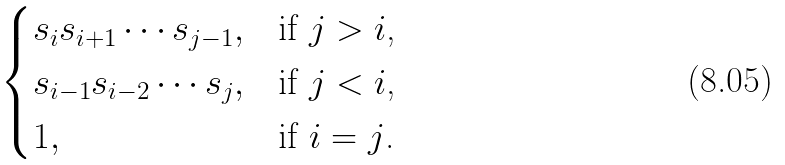<formula> <loc_0><loc_0><loc_500><loc_500>\begin{cases} s _ { i } s _ { i + 1 } \cdots s _ { j - 1 } , & \text {if $j>i$,} \\ s _ { i - 1 } s _ { i - 2 } \cdots s _ { j } , & \text {if $j<i$,} \\ 1 , & \text {if $i=j$.} \\ \end{cases}</formula> 